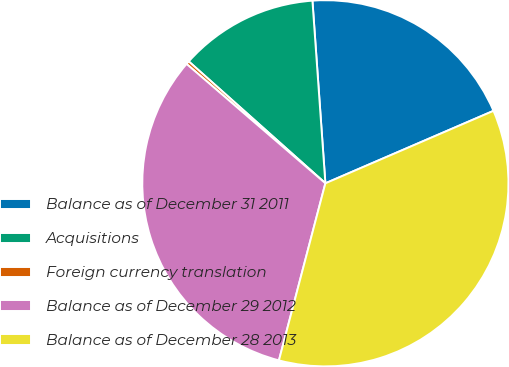<chart> <loc_0><loc_0><loc_500><loc_500><pie_chart><fcel>Balance as of December 31 2011<fcel>Acquisitions<fcel>Foreign currency translation<fcel>Balance as of December 29 2012<fcel>Balance as of December 28 2013<nl><fcel>19.65%<fcel>12.28%<fcel>0.29%<fcel>32.22%<fcel>35.56%<nl></chart> 